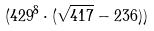<formula> <loc_0><loc_0><loc_500><loc_500>( 4 2 9 ^ { 8 } \cdot ( \sqrt { 4 1 7 } - 2 3 6 ) )</formula> 